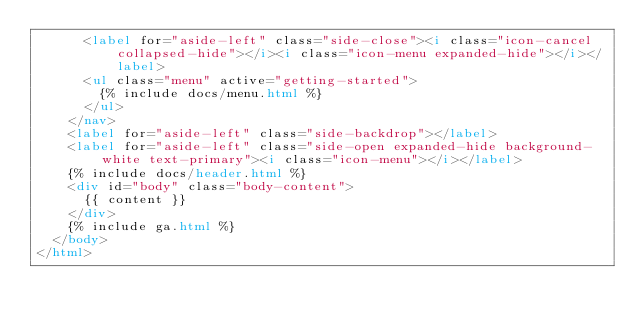<code> <loc_0><loc_0><loc_500><loc_500><_HTML_>      <label for="aside-left" class="side-close"><i class="icon-cancel collapsed-hide"></i><i class="icon-menu expanded-hide"></i></label>
      <ul class="menu" active="getting-started">
        {% include docs/menu.html %}
      </ul>
    </nav>
    <label for="aside-left" class="side-backdrop"></label>
    <label for="aside-left" class="side-open expanded-hide background-white text-primary"><i class="icon-menu"></i></label>
    {% include docs/header.html %}
    <div id="body" class="body-content">
      {{ content }}
    </div>
    {% include ga.html %}
  </body>
</html></code> 